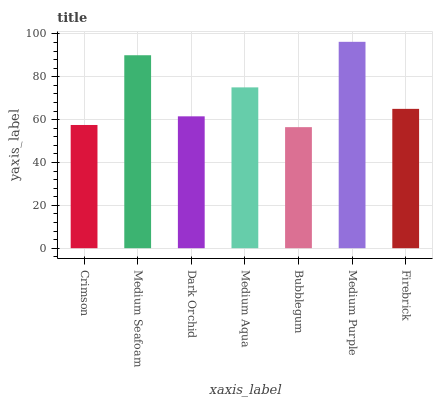Is Bubblegum the minimum?
Answer yes or no. Yes. Is Medium Purple the maximum?
Answer yes or no. Yes. Is Medium Seafoam the minimum?
Answer yes or no. No. Is Medium Seafoam the maximum?
Answer yes or no. No. Is Medium Seafoam greater than Crimson?
Answer yes or no. Yes. Is Crimson less than Medium Seafoam?
Answer yes or no. Yes. Is Crimson greater than Medium Seafoam?
Answer yes or no. No. Is Medium Seafoam less than Crimson?
Answer yes or no. No. Is Firebrick the high median?
Answer yes or no. Yes. Is Firebrick the low median?
Answer yes or no. Yes. Is Medium Aqua the high median?
Answer yes or no. No. Is Bubblegum the low median?
Answer yes or no. No. 